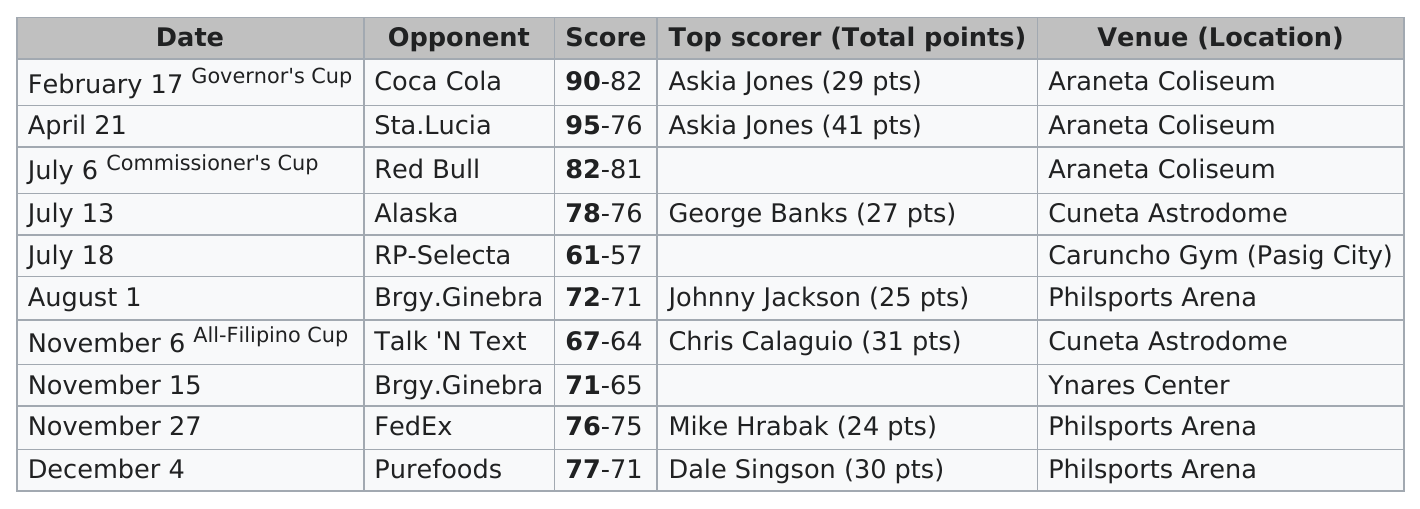Draw attention to some important aspects in this diagram. Askia Jones was the top scorer a total of two times. Thirty games were held at the Araneta Coliseum. Out of the total number of games played, only 7 games were not held at the Araneta Coliseum. Hrabak or Singson? Singson scored more points. Prior to facing Purefoods, the opponent that FedEx played was [insert opponent name]. 